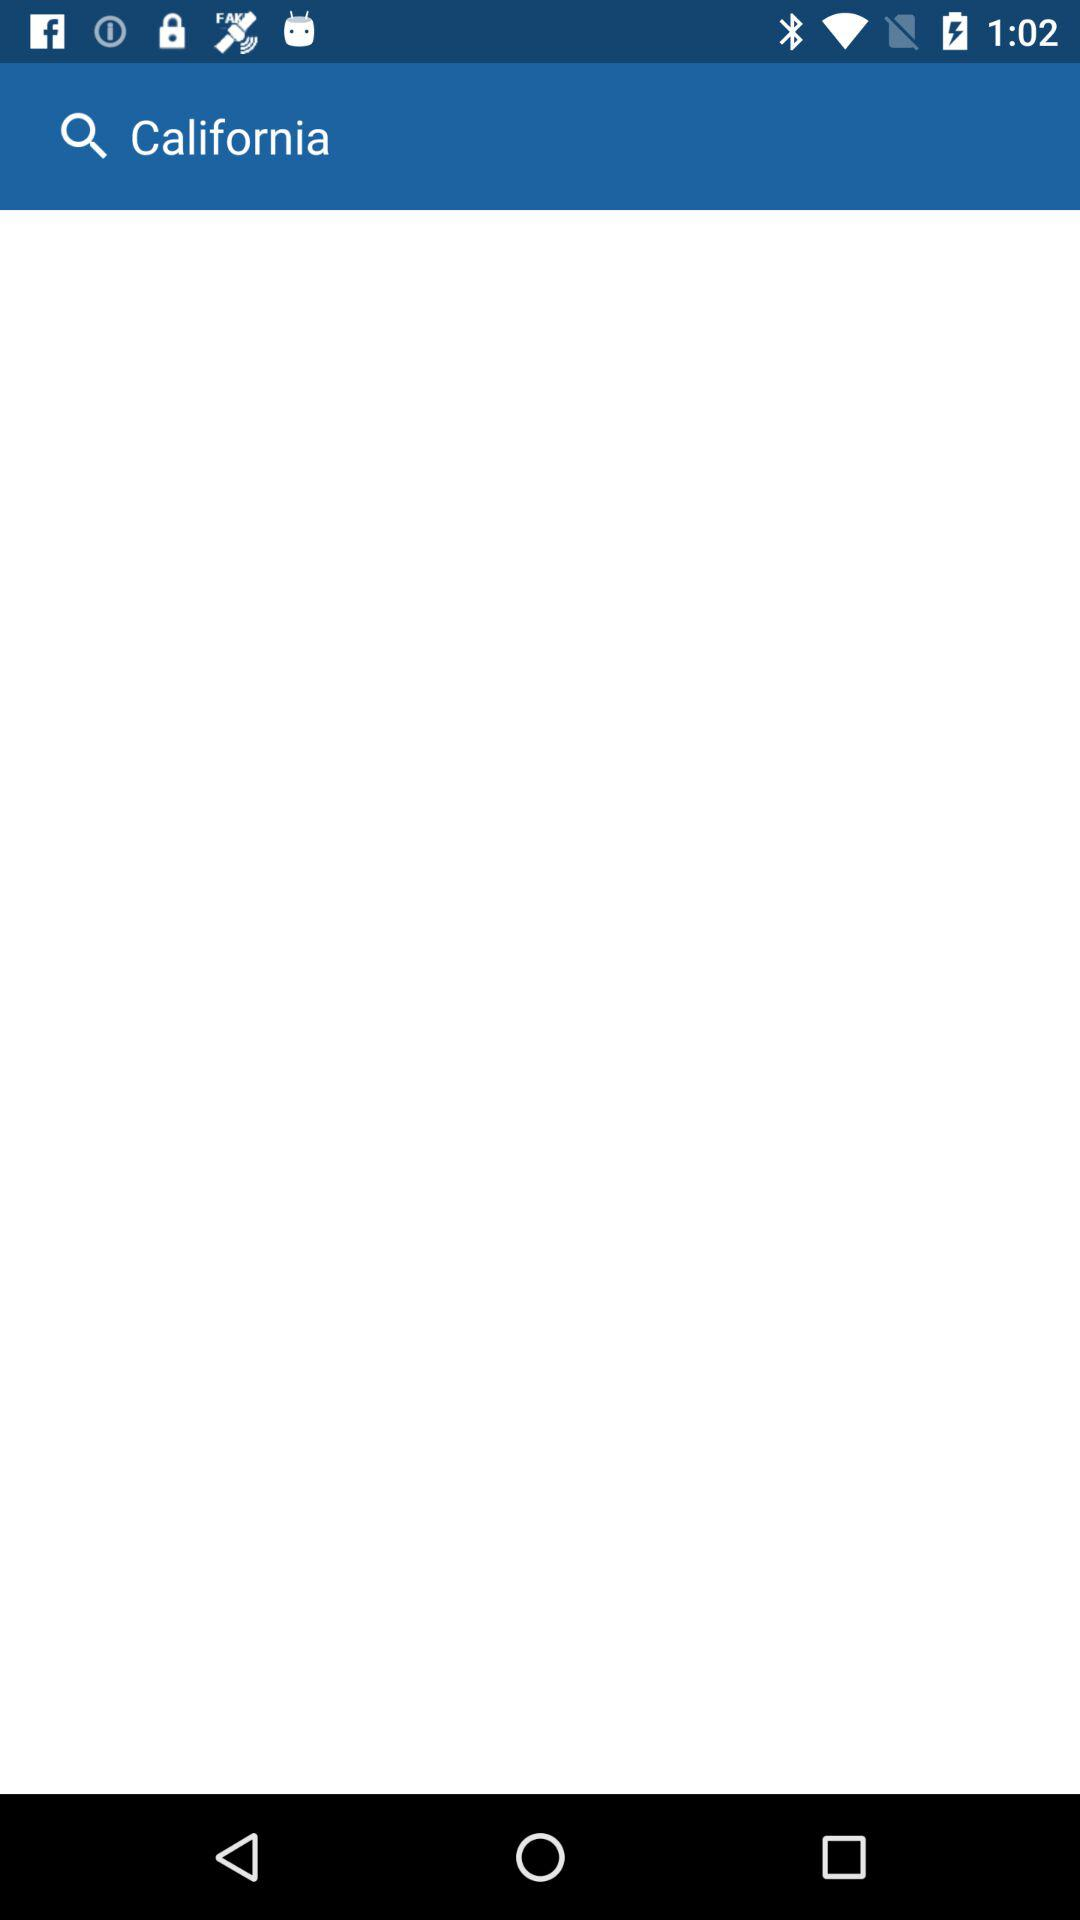What is the mentioned state? The mentioned state is California. 